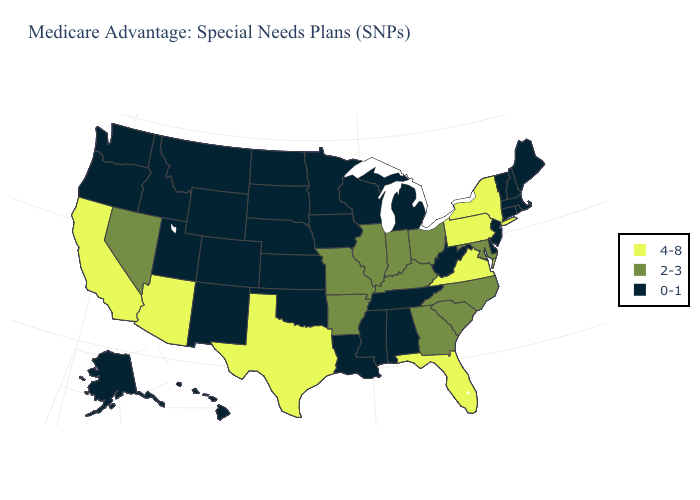What is the highest value in the USA?
Concise answer only. 4-8. What is the value of Connecticut?
Short answer required. 0-1. Name the states that have a value in the range 0-1?
Be succinct. Alaska, Alabama, Colorado, Connecticut, Delaware, Hawaii, Iowa, Idaho, Kansas, Louisiana, Massachusetts, Maine, Michigan, Minnesota, Mississippi, Montana, North Dakota, Nebraska, New Hampshire, New Jersey, New Mexico, Oklahoma, Oregon, Rhode Island, South Dakota, Tennessee, Utah, Vermont, Washington, Wisconsin, West Virginia, Wyoming. Name the states that have a value in the range 2-3?
Write a very short answer. Arkansas, Georgia, Illinois, Indiana, Kentucky, Maryland, Missouri, North Carolina, Nevada, Ohio, South Carolina. What is the value of Nevada?
Keep it brief. 2-3. What is the value of Nevada?
Write a very short answer. 2-3. Does Connecticut have the highest value in the Northeast?
Keep it brief. No. Name the states that have a value in the range 4-8?
Answer briefly. Arizona, California, Florida, New York, Pennsylvania, Texas, Virginia. Does Idaho have the same value as Wisconsin?
Quick response, please. Yes. Name the states that have a value in the range 0-1?
Concise answer only. Alaska, Alabama, Colorado, Connecticut, Delaware, Hawaii, Iowa, Idaho, Kansas, Louisiana, Massachusetts, Maine, Michigan, Minnesota, Mississippi, Montana, North Dakota, Nebraska, New Hampshire, New Jersey, New Mexico, Oklahoma, Oregon, Rhode Island, South Dakota, Tennessee, Utah, Vermont, Washington, Wisconsin, West Virginia, Wyoming. Which states hav the highest value in the Northeast?
Keep it brief. New York, Pennsylvania. Does Massachusetts have a lower value than South Carolina?
Short answer required. Yes. What is the lowest value in the Northeast?
Be succinct. 0-1. Which states have the highest value in the USA?
Write a very short answer. Arizona, California, Florida, New York, Pennsylvania, Texas, Virginia. What is the highest value in the USA?
Quick response, please. 4-8. 